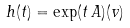Convert formula to latex. <formula><loc_0><loc_0><loc_500><loc_500>h ( t ) = \exp ( t \, A ) ( v )</formula> 